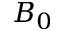<formula> <loc_0><loc_0><loc_500><loc_500>B _ { 0 }</formula> 